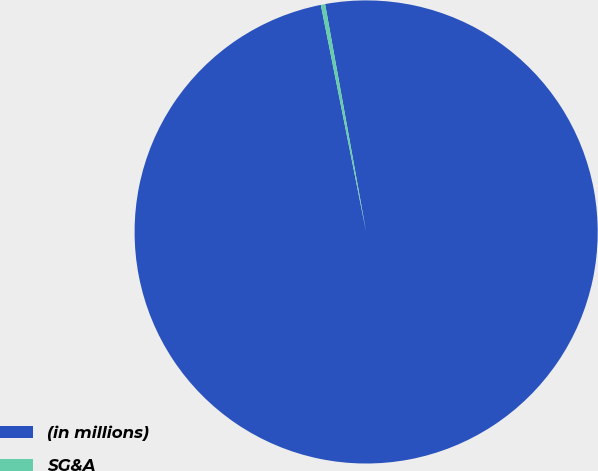Convert chart. <chart><loc_0><loc_0><loc_500><loc_500><pie_chart><fcel>(in millions)<fcel>SG&A<nl><fcel>99.7%<fcel>0.3%<nl></chart> 